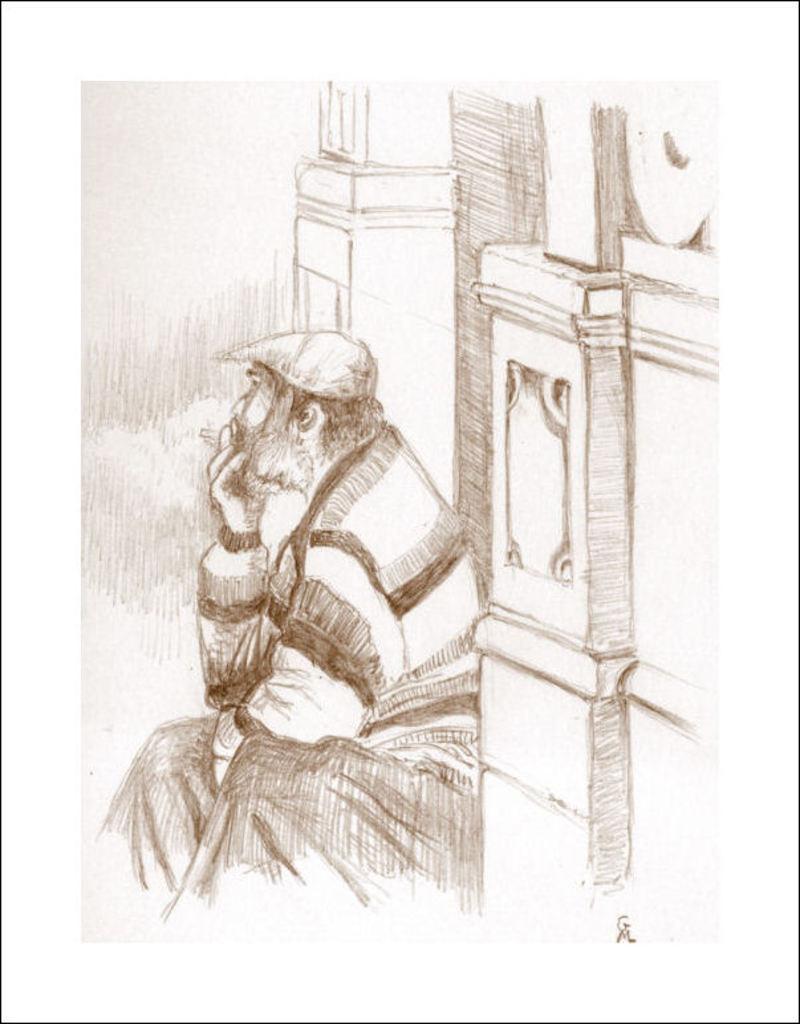Could you give a brief overview of what you see in this image? In this picture we can see a drawing of a man sitting and the wall. 